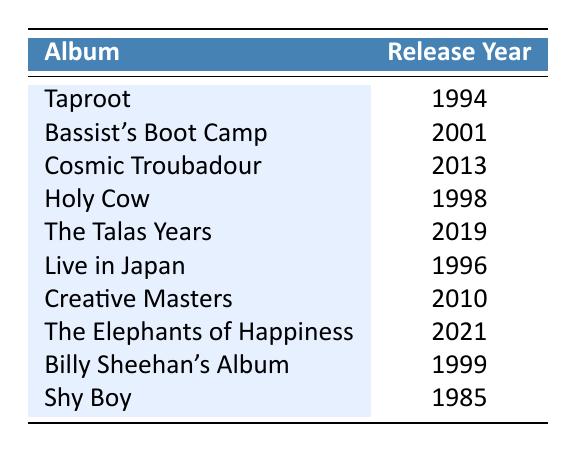What is the release year of the album "Taproot"? The album "Taproot" is listed in the table, and its corresponding release year is shown as 1994.
Answer: 1994 Which album was released in 2010? Looking at the table, the album with the release year 2010 is "Creative Masters."
Answer: Creative Masters Are there any albums released in the 1990s? By examining the years listed, the albums "Taproot," "Holy Cow," "Live in Japan," and "Billy Sheehan's Album" were all released in the 1990s.
Answer: Yes What is the most recent album released by Billy Sheehan? The table shows that "The Elephants of Happiness," released in 2021, is the latest album listed.
Answer: The Elephants of Happiness How many albums were released between 1994 and 2010? The albums released during that time are "Taproot" (1994), "Holy Cow" (1998), "Live in Japan" (1996), "Billy Sheehan's Album" (1999), "Bassist's Boot Camp" (2001), and "Creative Masters" (2010). Counting them gives us 6 albums.
Answer: 6 Which album was released closest to the year 2000? The albums around the year 2000 are "Bassist's Boot Camp" (2001) and "Billy Sheehan's Album" (1999). "Billy Sheehan's Album" is closer to the year 2000 since it was released one year earlier.
Answer: Billy Sheehan's Album What is the average release year of the albums listed in the table? To find the average, sum the release years: 1994 + 2001 + 2013 + 1998 + 2019 + 1996 + 2010 + 2021 + 1999 + 1985 = 20096. Then divide by the number of albums, which is 10: 20096 / 10 = 2009.6. Rounding gives an average release year of approximately 2010.
Answer: 2010 Which album has the longest gap in years between releases? The album "Shy Boy" (1985) and "Bassist's Boot Camp" (2001) shows the longest gap of 16 years.
Answer: 16 years Is "Cosmic Troubadour" the only album released after 2010? Checking the release years, "Cosmic Troubadour" (2013), "The Talas Years" (2019), and "The Elephants of Happiness" (2021) were released after 2010, so it is not the only one.
Answer: No Counting the albums, how many were released in the 21st century? The albums released in the 21st century are "Bassist's Boot Camp" (2001), "Creative Masters" (2010), "Cosmic Troubadour" (2013), "The Talas Years" (2019), and "The Elephants of Happiness" (2021). That gives us a total of 5 albums.
Answer: 5 